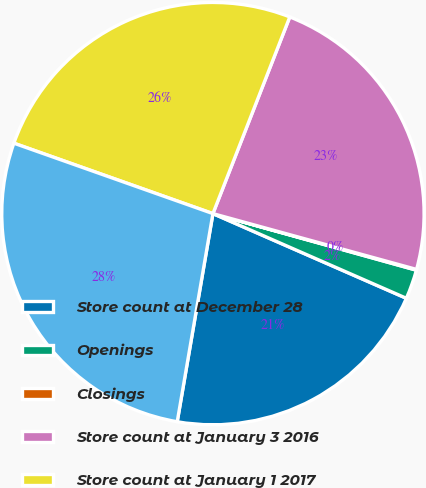Convert chart to OTSL. <chart><loc_0><loc_0><loc_500><loc_500><pie_chart><fcel>Store count at December 28<fcel>Openings<fcel>Closings<fcel>Store count at January 3 2016<fcel>Store count at January 1 2017<fcel>Store count at December 31<nl><fcel>21.14%<fcel>2.25%<fcel>0.06%<fcel>23.33%<fcel>25.52%<fcel>27.71%<nl></chart> 